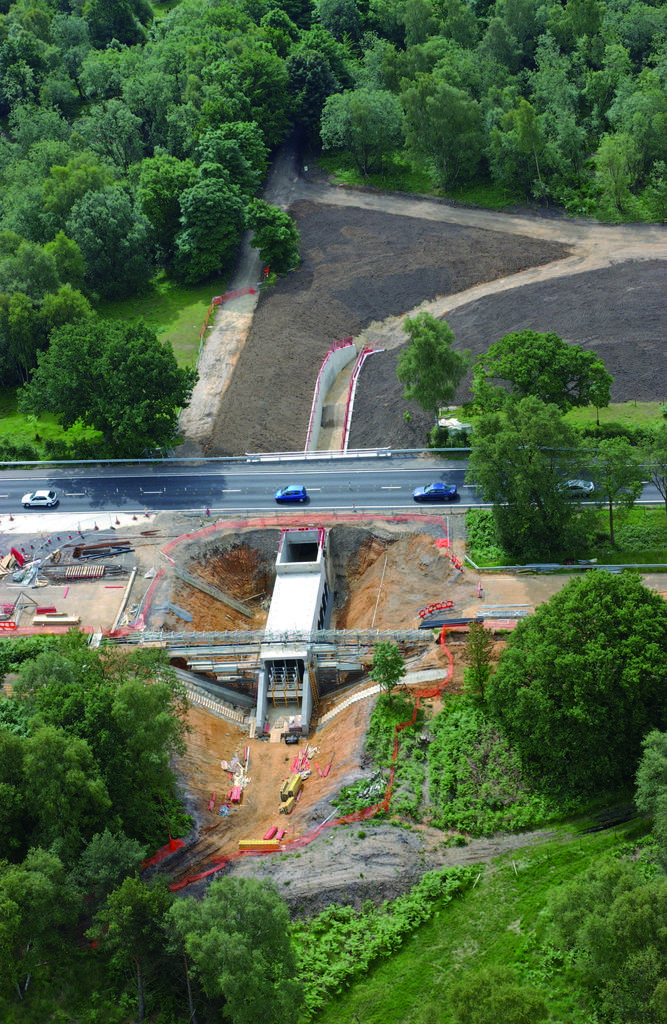How would you summarize this image in a sentence or two? In the center of the image there is a bridge. There are cars on the road. Beside the road there are few objects. In the background of the image there are trees. At the bottom of the image there is sand. 